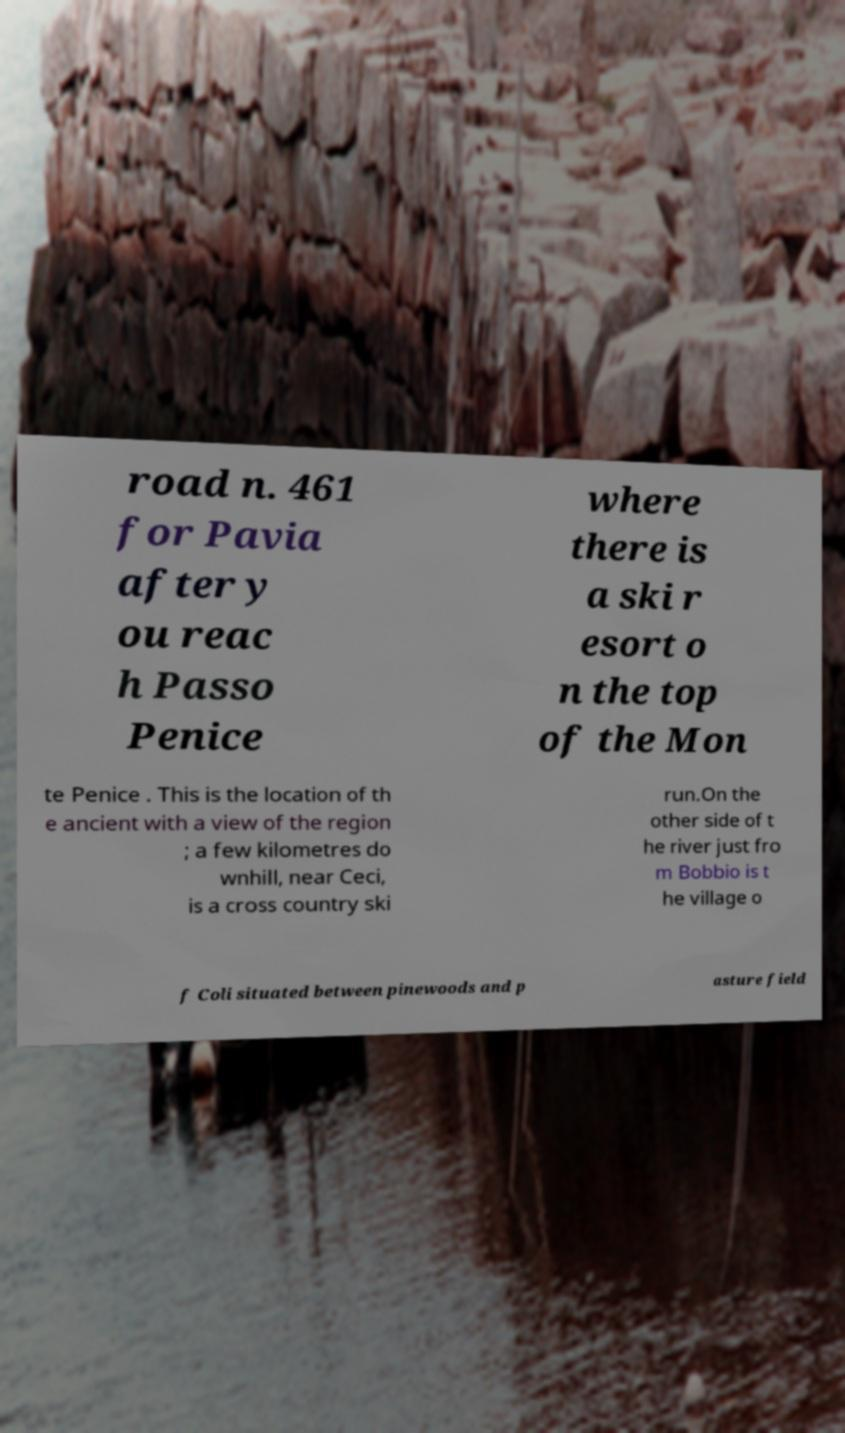Can you read and provide the text displayed in the image?This photo seems to have some interesting text. Can you extract and type it out for me? road n. 461 for Pavia after y ou reac h Passo Penice where there is a ski r esort o n the top of the Mon te Penice . This is the location of th e ancient with a view of the region ; a few kilometres do wnhill, near Ceci, is a cross country ski run.On the other side of t he river just fro m Bobbio is t he village o f Coli situated between pinewoods and p asture field 